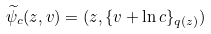<formula> <loc_0><loc_0><loc_500><loc_500>\widetilde { \psi } _ { c } ( z , v ) = ( z , \{ v + \ln c \} _ { q ( z ) } )</formula> 